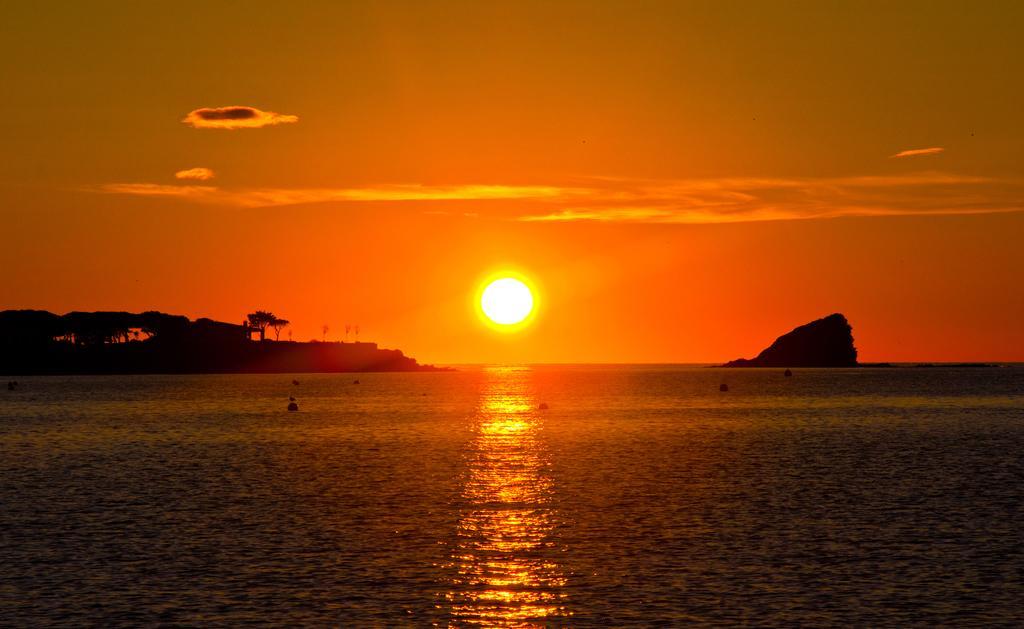How would you summarize this image in a sentence or two? In this image we can see an ocean. Background of the image, trees are there. We can see sun in the sky. 